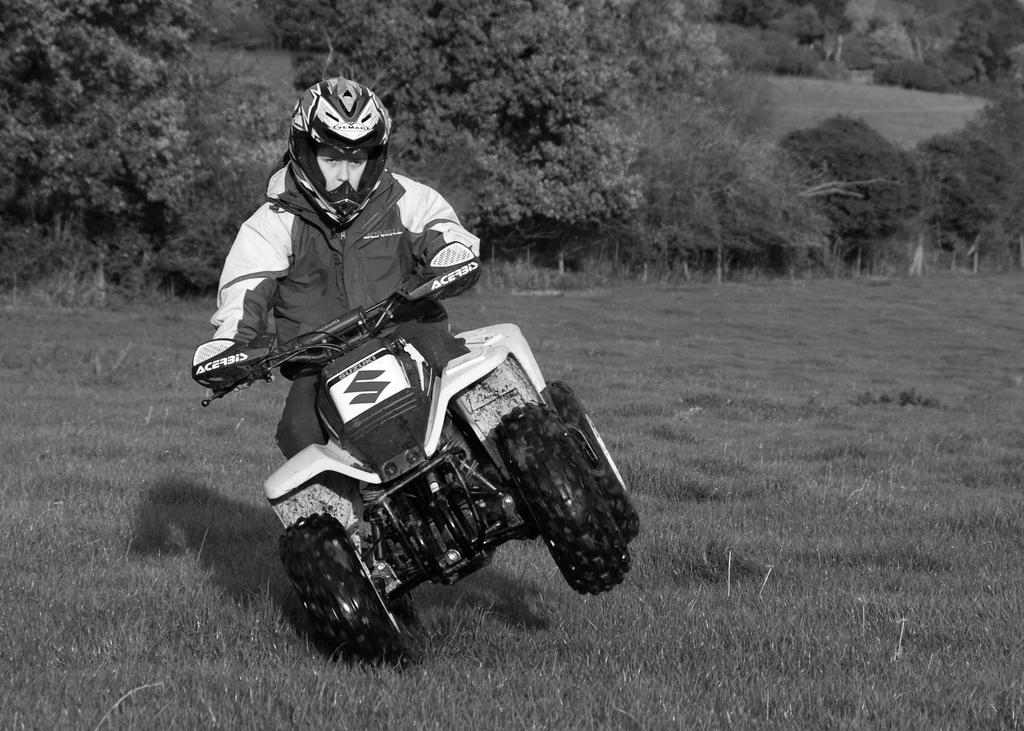What is the main subject of the image? There is a person riding a motorcycle in the image. What type of natural environment can be seen in the image? Trees and grass are visible in the image. What religion is the person riding the motorcycle practicing in the image? There is no information about the person's religion in the image. How many times does the person ride the motorcycle in the image? The image only shows the person riding the motorcycle once, so it is not possible to determine how many times they ride it. 